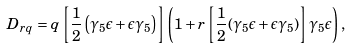Convert formula to latex. <formula><loc_0><loc_0><loc_500><loc_500>D _ { r q } = q \left [ \frac { 1 } { 2 } \left ( \gamma _ { 5 } \epsilon + \epsilon \gamma _ { 5 } \right ) \right ] \left ( 1 + r \left [ \frac { 1 } { 2 } ( \gamma _ { 5 } \epsilon + \epsilon \gamma _ { 5 } ) \right ] \gamma _ { 5 } \epsilon \right ) ,</formula> 